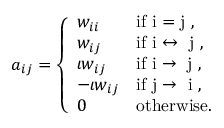Convert formula to latex. <formula><loc_0><loc_0><loc_500><loc_500>a _ { i j } = \left \{ \begin{array} { l l } { w _ { i i } } & { i f i = j , } \\ { w _ { i j } } & { i f i \leftrightarrow j , } \\ { \iota w _ { i j } } & { i f i \rightarrow j , } \\ { - \iota w _ { i j } } & { i f j \rightarrow i , } \\ { 0 } & { o t h e r w i s e . } \end{array}</formula> 